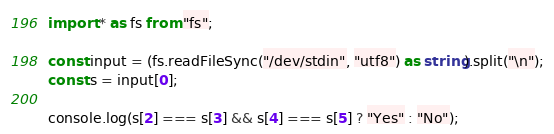Convert code to text. <code><loc_0><loc_0><loc_500><loc_500><_TypeScript_>import * as fs from "fs";

const input = (fs.readFileSync("/dev/stdin", "utf8") as string).split("\n");
const s = input[0];

console.log(s[2] === s[3] && s[4] === s[5] ? "Yes" : "No");
</code> 